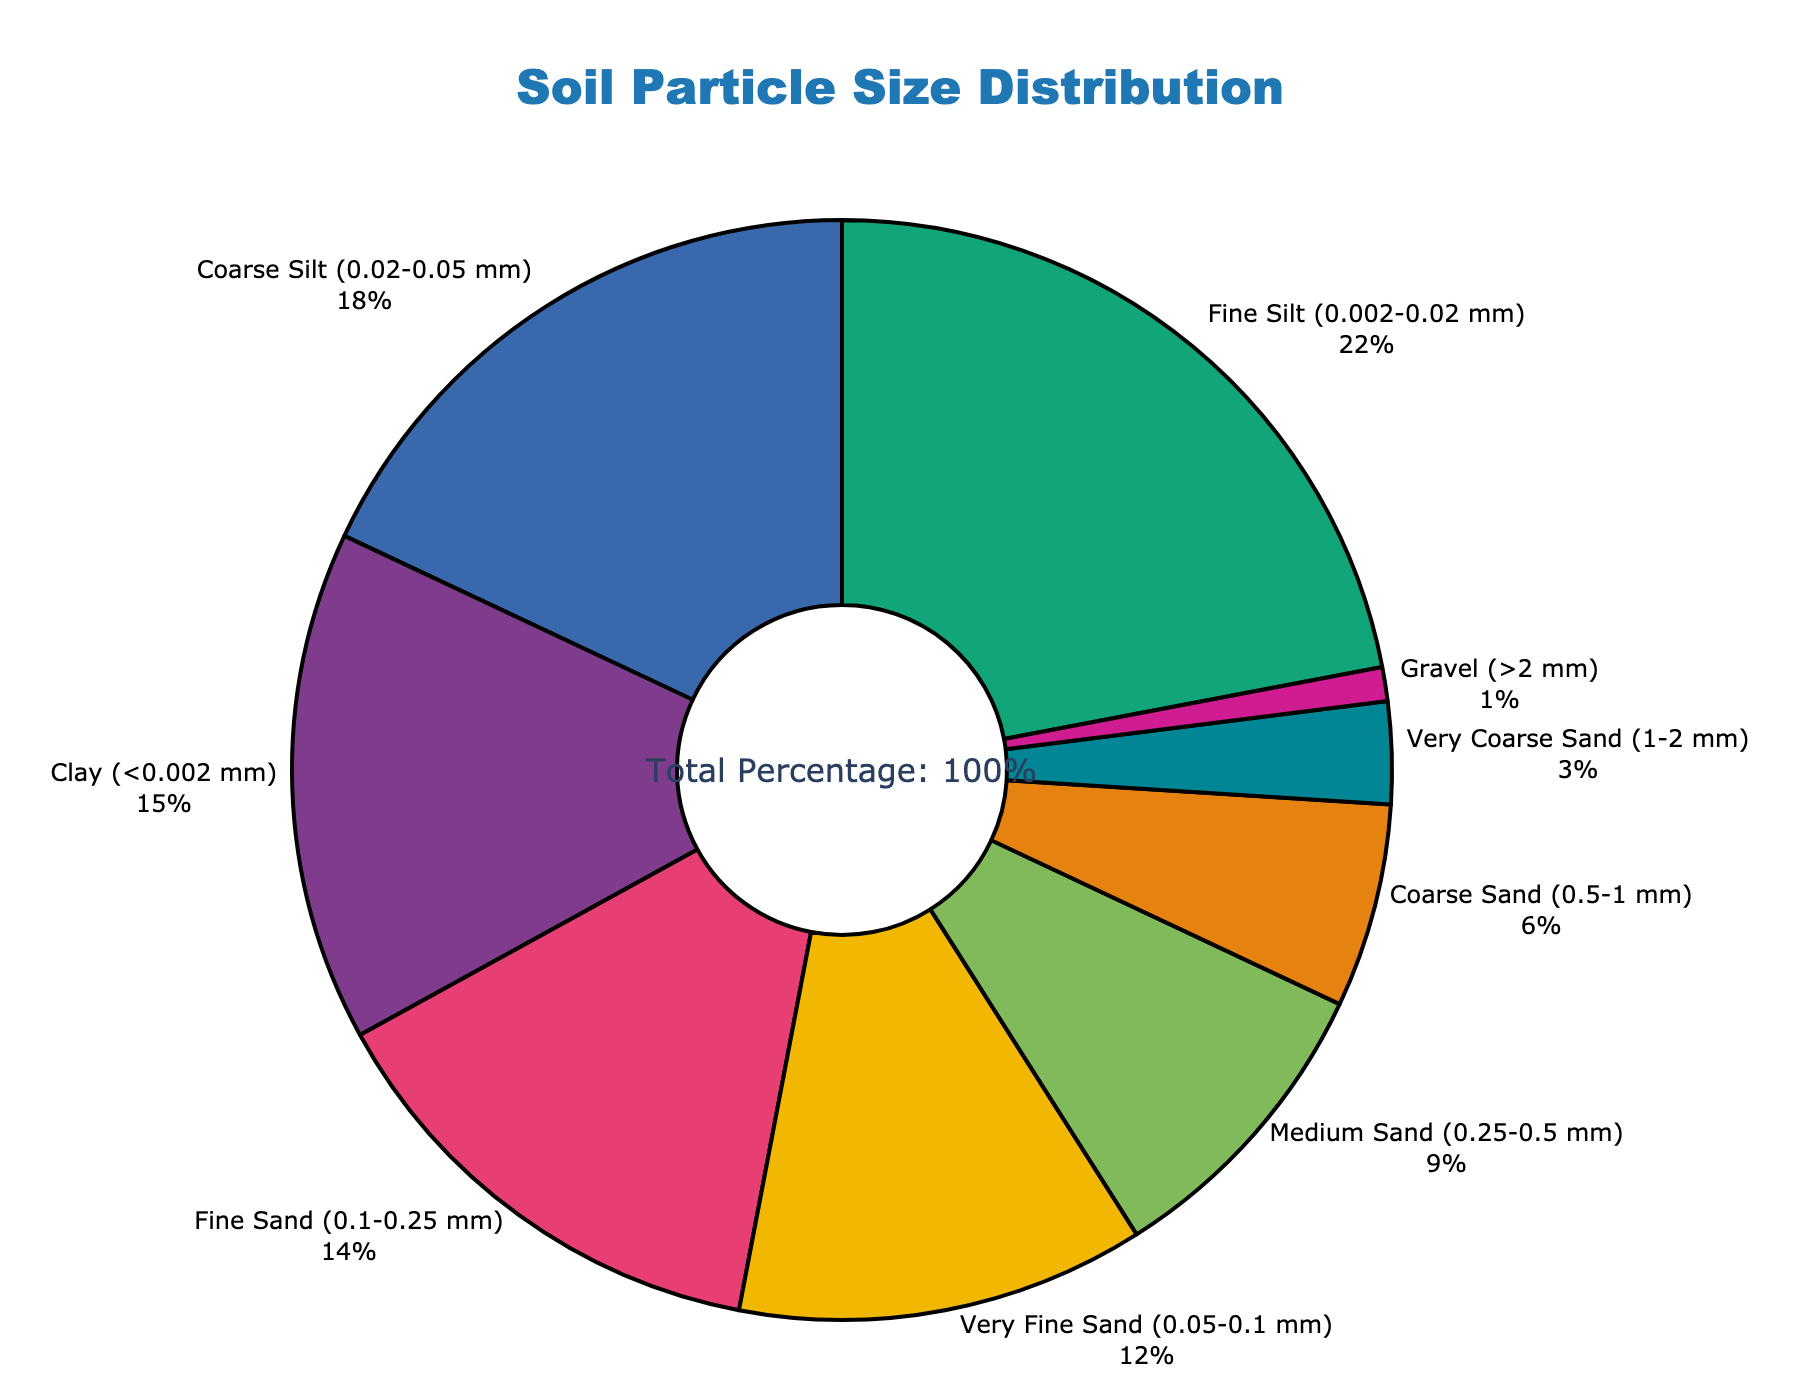which particle size group constitutes the largest percentage of the soil composition? By examining the pie chart, we find that the "Fine Silt (0.002-0.02 mm)" segment is the largest, comprising 22% of the soil composition.
Answer: Fine Silt (0.002-0.02 mm) what is the combined percentage of clay and coarse sand in the soil? The chart shows Clay at 15% and Coarse Sand at 6%. Adding these percentages together gives 15% + 6% = 21%.
Answer: 21% how does the percentage of very fine sand compare to medium sand? Very Fine Sand represents 12% of the soil, while Medium Sand forms 9%. 12% is greater than 9%.
Answer: Very Fine Sand has a higher percentage what three particle sizes have the smallest percentages? Looking at the portions of the pie chart, Gravel (1%), Very Coarse Sand (3%), and Coarse Sand (6%) have the smallest percentages.
Answer: Gravel, Very Coarse Sand, Coarse Sand what is the average percentage of the three silt categories? The percentages for Fine Silt, Coarse Silt, and Very Fine Sand are 22%, 18%, and 12% respectively. The average is calculated as (22% + 18% + 12%) / 3 = 52% / 3 = 17.33%.
Answer: 17.33% which particle size, among those that make up more than 10% of the soil, has the lowest percentage? Categories more than 10% are Fine Silt (22%), Clay (15%), Coarse Silt (18%), and Very Fine Sand (12%). Among these, Very Fine Sand is the lowest at 12%.
Answer: Very Fine Sand what is the difference in percentage between fine sand and coarse sand? Fine Sand accounts for 14% and Coarse Sand is 6%. The difference is computed as 14% - 6% = 8%.
Answer: 8% what portion of the soil composition is represented by particles smaller than 0.05 mm? Particle sizes smaller than 0.05 mm include Clay (15%), Fine Silt (22%), and Coarse Silt (18%). Summing these gives 15% + 22% + 18% = 55%.
Answer: 55% how much larger is the percentage of very coarse sand compared to the percentage of gravel? Very Coarse Sand is 3% and Gravel is 1%. The difference is 3% - 1% = 2%.
Answer: 2% what is the total percentage of sand (very fine, fine, medium, coarse, and very coarse)? The percentages are Very Fine Sand (12%), Fine Sand (14%), Medium Sand (9%), Coarse Sand (6%), and Very Coarse Sand (3%). Adding them gives 12% + 14% + 9% + 6% + 3% = 44%.
Answer: 44% 